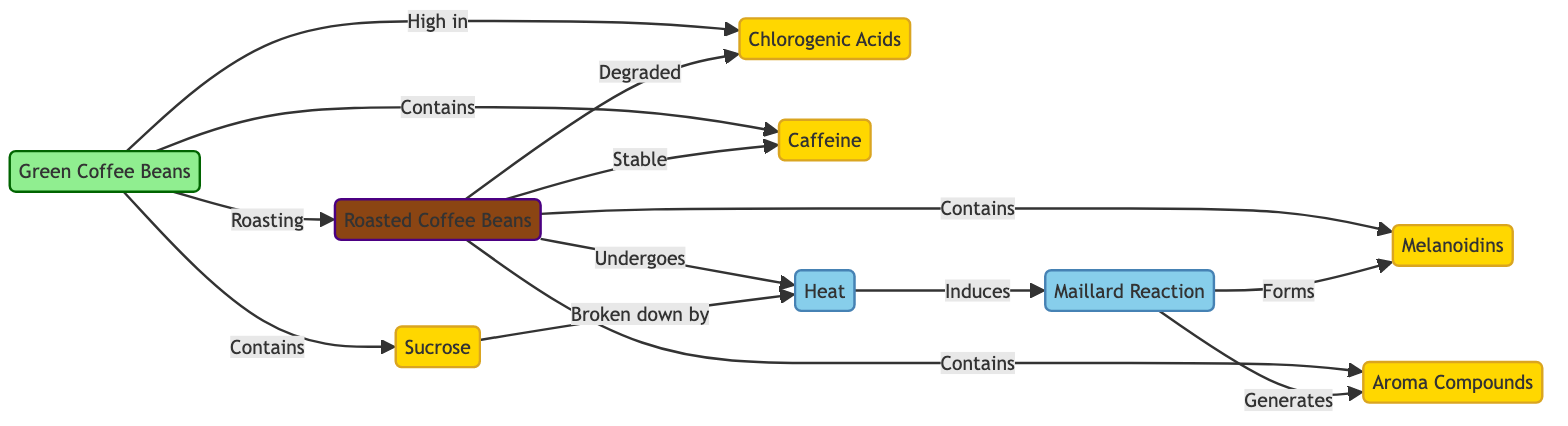1. What type of acids are high in green coffee beans? The diagram indicates that green coffee beans are high in chlorogenic acids, which is specifically mentioned as a direct relationship from the green coffee beans node.
Answer: chlorogenic acids 2. How does roasting affect chlorogenic acids in roasted coffee? According to the diagram, roasted coffee degrades chlorogenic acids, as shown by the direct link from the roasted coffee node to the chlorogenic acids node with the label "Degraded."
Answer: Degraded 3. Which compounds are present in roasted coffee beans? The diagram lists melanoidins and aroma compounds as being present in roasted coffee beans, represented by directed connections from the roasted coffee node to both compound nodes.
Answer: melanoidins, aroma compounds 4. What process occurs under heat during roasting? The diagram illustrates that the maillard reaction occurs under heat, shown by the link from the heat node to the maillard reaction node.
Answer: maillard reaction 5. What relationship exists between sucrose and heat during roasting? The diagram indicates that sucrose is broken down by heat, which establishes a clear direct relationship from the sucrose node to the heat node.
Answer: Broken down by 6. How does caffeine stability compare between green and roasted coffee? The diagram indicates that caffeine remains stable in roasted coffee, as depicted by the directed relationship labeled "Stable" from the roasted coffee node to the caffeine node, contrasting with its presence in green coffee.
Answer: Stable 7. How does roasting influence the compounds present in coffee? The diagram illustrates that roasting transforms green coffee beans into roasted coffee, while changing the composition of compounds (degrading chlorogenic acids and generating melanoidins and aroma compounds), indicating a key transformation process.
Answer: Changes composition 8. What chemicals are broken down during the roasting process? The diagram specifically points out sucrose as being broken down by heat, indicating that this is a component that undergoes change during the roasting process.
Answer: Sucrose 9. Number of chemical compounds represented in the diagram? The diagram shows a total of five distinct compound nodes: chlorogenic acids, caffeine, sucrose, melanoidins, and aroma compounds.
Answer: 5 10. What type of chemical reaction is relevant in the roasting of coffee? The diagram emphasizes the maillard reaction as significant in the coffee roasting process, showcasing it as a key reaction occurring when heat is applied.
Answer: Maillard Reaction 